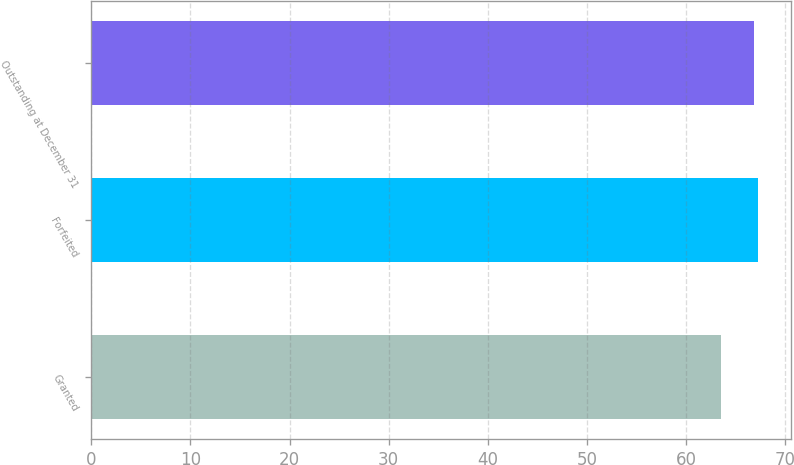<chart> <loc_0><loc_0><loc_500><loc_500><bar_chart><fcel>Granted<fcel>Forfeited<fcel>Outstanding at December 31<nl><fcel>63.5<fcel>67.27<fcel>66.89<nl></chart> 